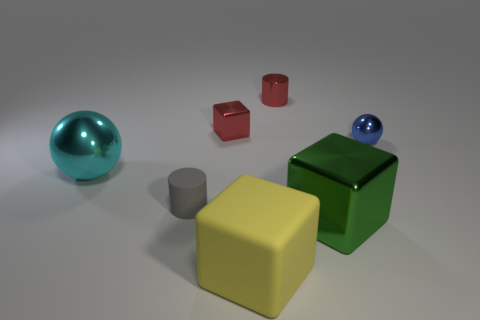Subtract all rubber blocks. How many blocks are left? 2 Subtract all green blocks. How many blocks are left? 2 Subtract all balls. How many objects are left? 5 Add 2 tiny metallic balls. How many objects exist? 9 Subtract 3 blocks. How many blocks are left? 0 Subtract all brown blocks. How many blue balls are left? 1 Subtract 0 green balls. How many objects are left? 7 Subtract all blue balls. Subtract all yellow cubes. How many balls are left? 1 Subtract all cyan metal cubes. Subtract all rubber cylinders. How many objects are left? 6 Add 7 gray rubber things. How many gray rubber things are left? 8 